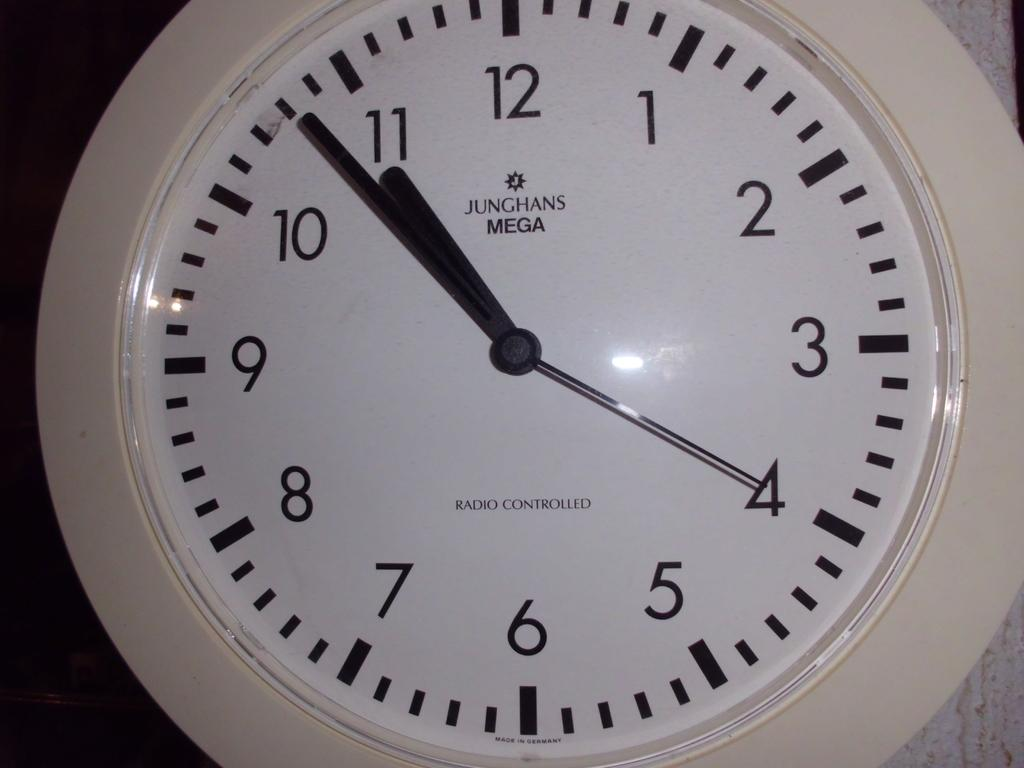Provide a one-sentence caption for the provided image. A white analouge clock with black hands and numbers at 10:50. 